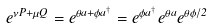<formula> <loc_0><loc_0><loc_500><loc_500>e ^ { \nu P + \mu Q } = e ^ { \theta a + \phi a ^ { \dagger } } = e ^ { \phi a ^ { \dagger } } e ^ { \theta a } e ^ { \theta \phi / 2 }</formula> 